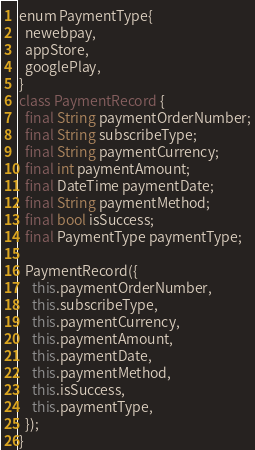<code> <loc_0><loc_0><loc_500><loc_500><_Dart_>enum PaymentType{
  newebpay,
  appStore,
  googlePlay,
}
class PaymentRecord {
  final String paymentOrderNumber;
  final String subscribeType;
  final String paymentCurrency;
  final int paymentAmount;
  final DateTime paymentDate;
  final String paymentMethod;
  final bool isSuccess;
  final PaymentType paymentType;

  PaymentRecord({
    this.paymentOrderNumber,
    this.subscribeType,
    this.paymentCurrency,
    this.paymentAmount,
    this.paymentDate,
    this.paymentMethod,
    this.isSuccess,
    this.paymentType,
  });
}</code> 